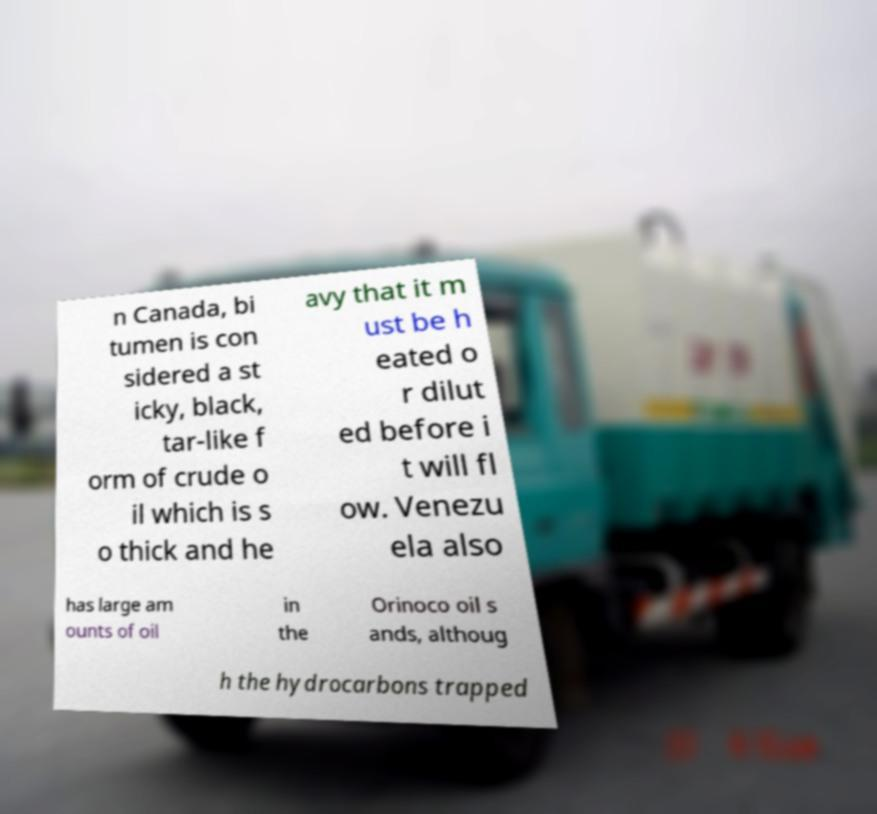Could you assist in decoding the text presented in this image and type it out clearly? n Canada, bi tumen is con sidered a st icky, black, tar-like f orm of crude o il which is s o thick and he avy that it m ust be h eated o r dilut ed before i t will fl ow. Venezu ela also has large am ounts of oil in the Orinoco oil s ands, althoug h the hydrocarbons trapped 